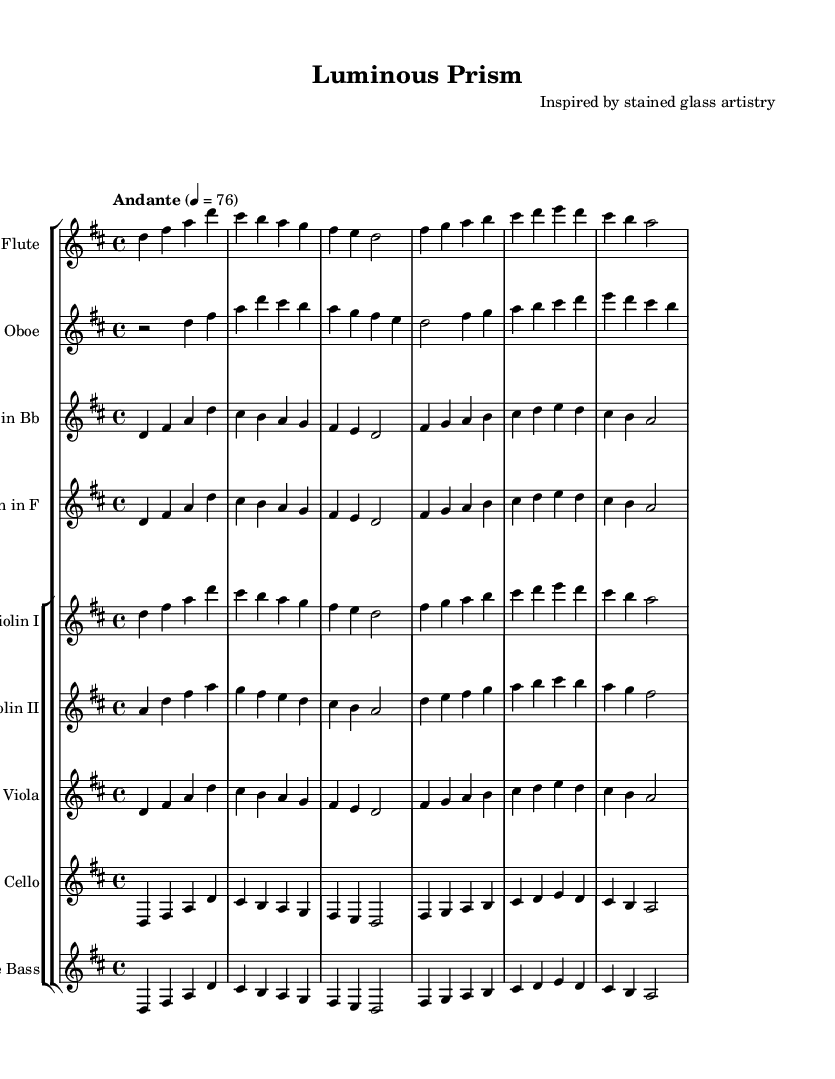What is the key signature of this music? The key signature is indicated by the sharp signs located at the beginning of the staff. In this case, there are two sharps, which corresponds to the key of D major.
Answer: D major What is the time signature for this composition? The time signature is found at the beginning of the staff and indicates the number of beats in a measure. Here, it is noted as 4/4, meaning there are four beats in each measure.
Answer: 4/4 What is the tempo marking of the piece? The tempo marking is expressed above the staff, indicating how fast the piece should be played. In this sheet music, it is labeled "Andante" with a metronome marking of 76, indicating a moderate pace.
Answer: Andante 4 = 76 Which instruments are included in the score? The instruments are listed above their respective staves. The score includes flute, oboe, clarinet in B flat, horn in F, violins I and II, viola, cello, and double bass.
Answer: Flute, Oboe, Clarinet in B flat, Horn in F, Violin I, Violin II, Viola, Cello, Double Bass How many measures are present in the first section of the music? To determine the number of measures, count the vertical bar lines that separate the notes. Here, there are six measures visible in the first section being analyzed.
Answer: 6 Which instruments play the same melody in the second half of the piece? Examining the scores for the second half shows that the flute, violin I, viola, and cello are playing the same melodic phrases, indicating that they share the same musical line.
Answer: Flute, Violin I, Viola, Cello 